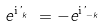Convert formula to latex. <formula><loc_0><loc_0><loc_500><loc_500>e ^ { \text {i} \varphi ^ { \ } _ { k } } = - e ^ { \text {i} \varphi ^ { \ } _ { - k } }</formula> 